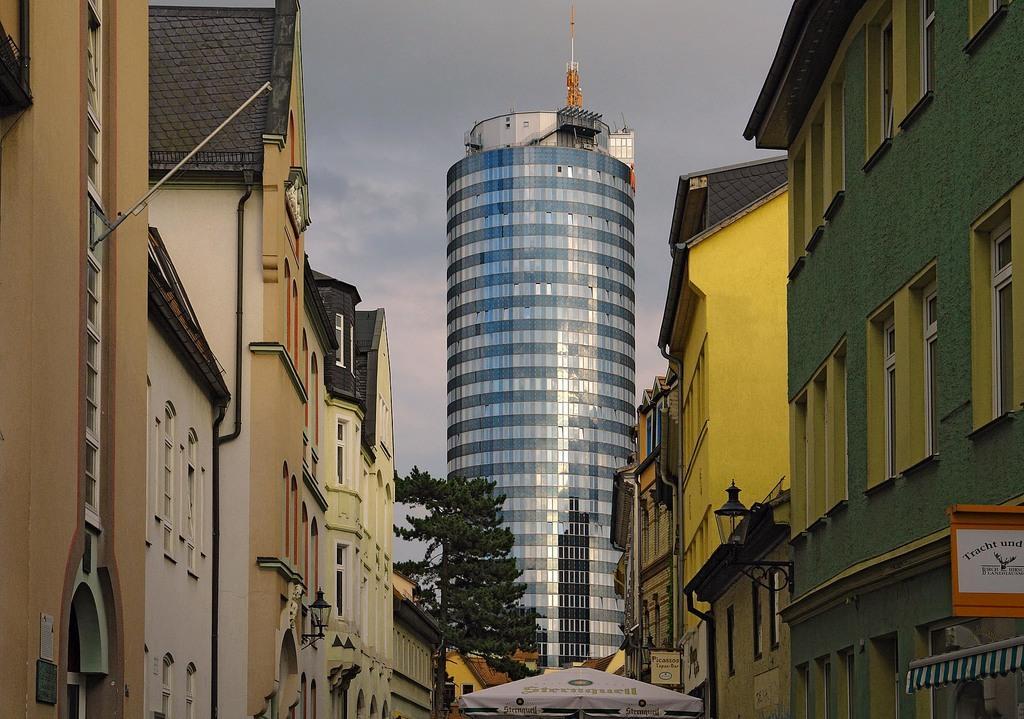In one or two sentences, can you explain what this image depicts? In this image we can see a few buildings, there are some windows, boards and lights, also we can see a tree and a tent, in the background, we can see the sky with clouds. 